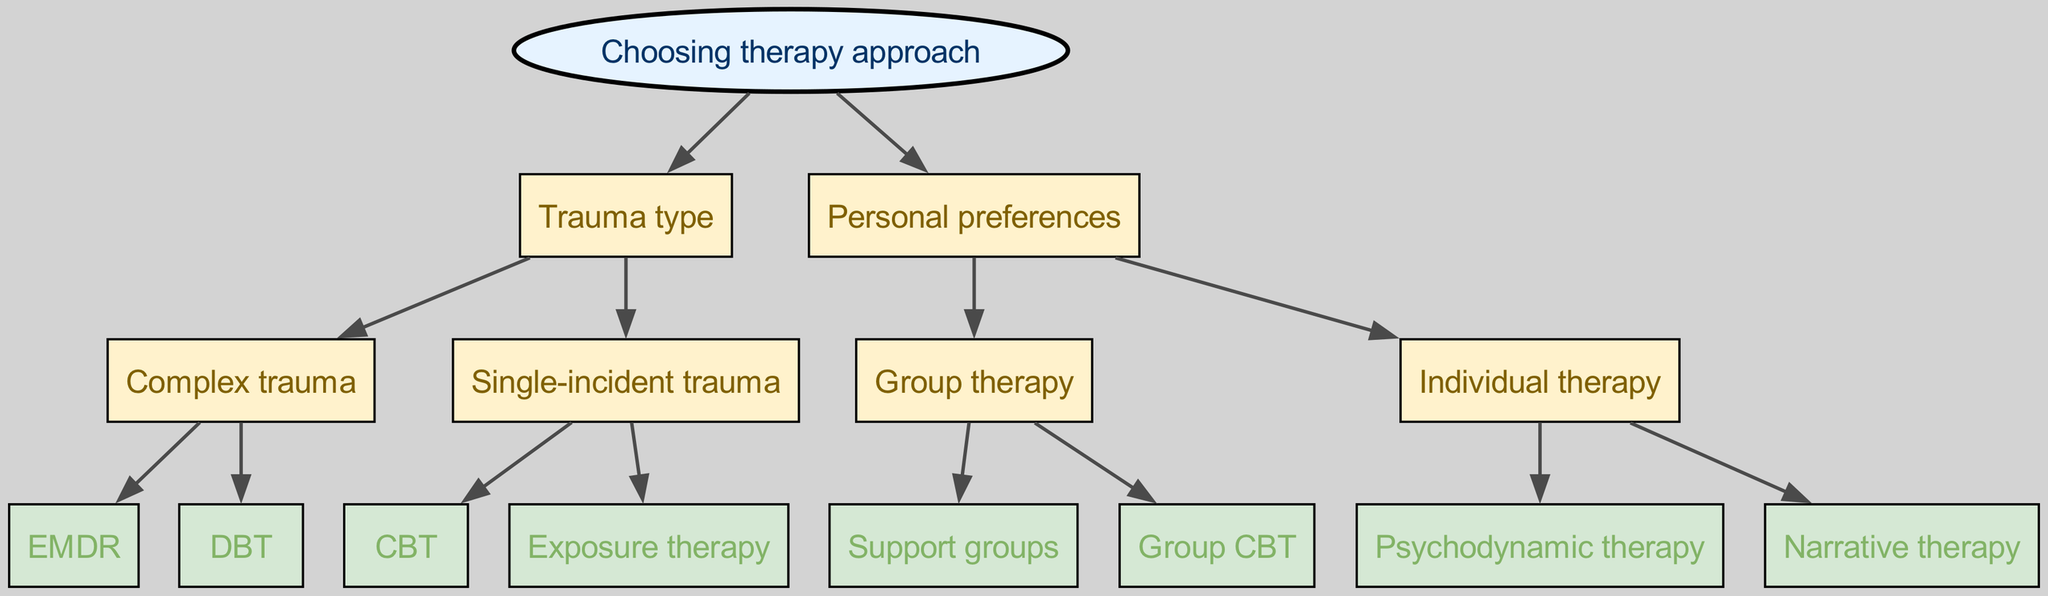What are the two main categories at the root of the diagram? The root of the diagram indicates the two main categories as "Trauma type" and "Personal preferences."
Answer: Trauma type, Personal preferences How many therapy approaches are listed for complex trauma? Under the category of complex trauma, there are two therapy approaches listed: EMDR and DBT.
Answer: 2 What therapy approach is recommended for single-incident trauma? The therapies available for single-incident trauma are CBT and Exposure therapy. Thus, either of these is recommended depending on the individual's preference.
Answer: CBT, Exposure therapy Which therapy is available under group therapy? There are two therapy options listed under group therapy: Support groups and Group CBT.
Answer: Support groups, Group CBT Which therapy is categorized under individual therapy? Individual therapy features two therapy options: Psychodynamic therapy and Narrative therapy.
Answer: Psychodynamic therapy, Narrative therapy If a person prefers group therapy and seeks support for complex trauma, which therapy approaches would be suitable? A person who prefers group therapy and has complex trauma would consider Support groups or Group CBT, as these options fall under the Group therapy category.
Answer: Support groups, Group CBT What type of therapy is specifically provided for complex trauma? For complex trauma, the therapies provided in the diagram are EMDR and DBT. Therefore, either can be chosen based on personal preference.
Answer: EMDR, DBT How many total therapy approaches are available in the diagram? There are a total of six therapy approaches in the diagram: EMDR, DBT, CBT, Exposure therapy, Support groups, and Group CBT, as well as Psychodynamic therapy and Narrative therapy listed under individual therapy.
Answer: 8 